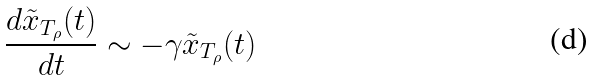Convert formula to latex. <formula><loc_0><loc_0><loc_500><loc_500>\frac { d \tilde { x } _ { T _ { \rho } } ( t ) } { d t } \sim - \gamma \tilde { x } _ { T _ { \rho } } ( t )</formula> 